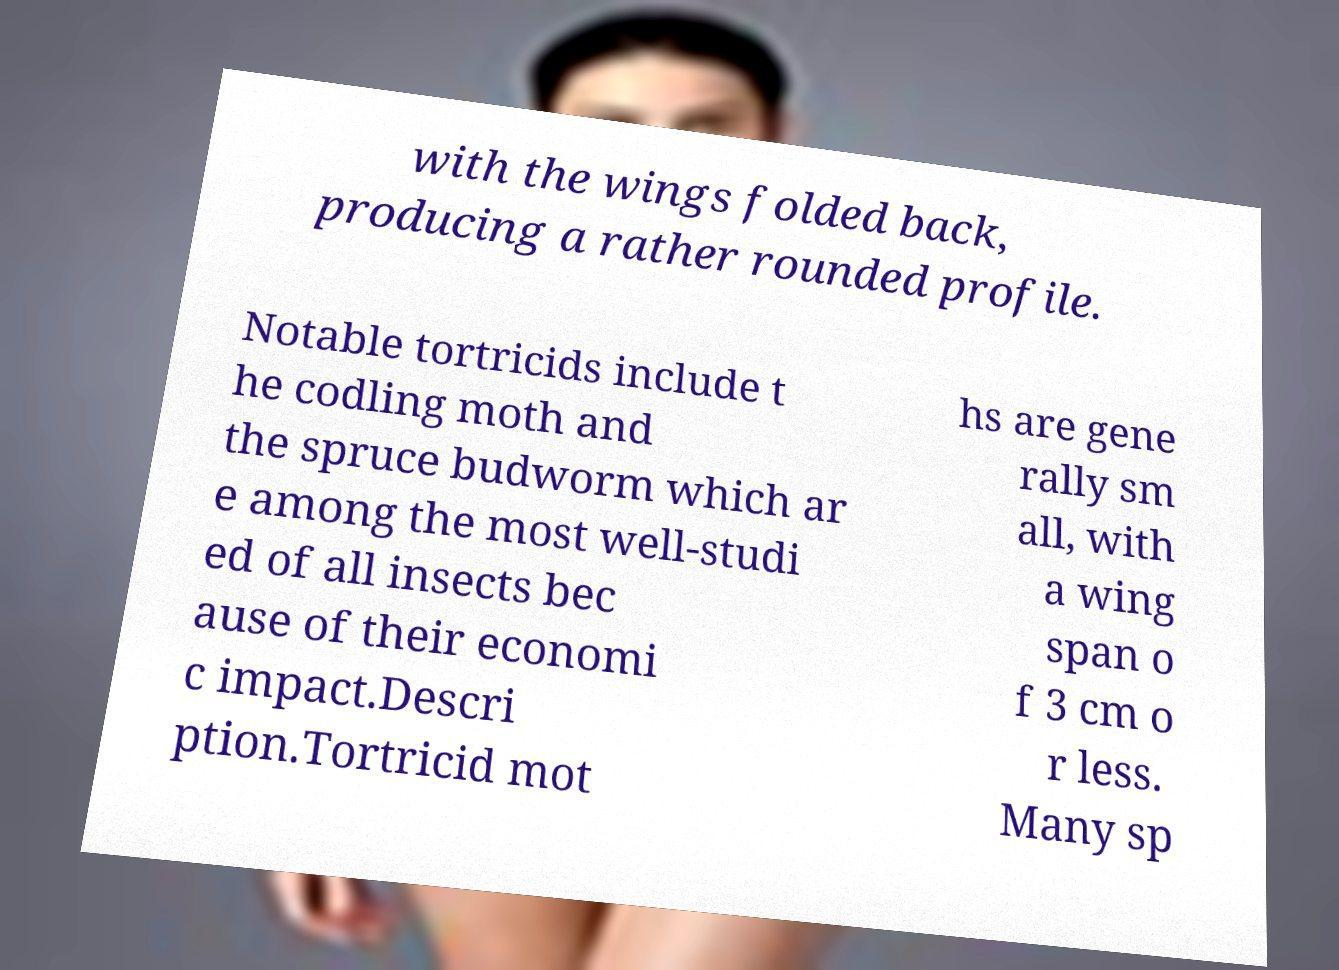Please identify and transcribe the text found in this image. with the wings folded back, producing a rather rounded profile. Notable tortricids include t he codling moth and the spruce budworm which ar e among the most well-studi ed of all insects bec ause of their economi c impact.Descri ption.Tortricid mot hs are gene rally sm all, with a wing span o f 3 cm o r less. Many sp 